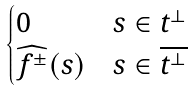<formula> <loc_0><loc_0><loc_500><loc_500>\begin{cases} 0 & s \in t ^ { \bot } \\ \widehat { f ^ { \pm } } ( s ) & s \in \overline { t ^ { \bot } } \end{cases}</formula> 